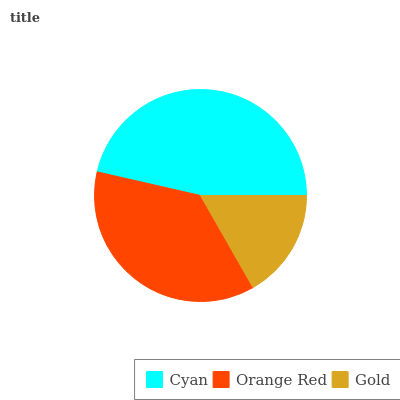Is Gold the minimum?
Answer yes or no. Yes. Is Cyan the maximum?
Answer yes or no. Yes. Is Orange Red the minimum?
Answer yes or no. No. Is Orange Red the maximum?
Answer yes or no. No. Is Cyan greater than Orange Red?
Answer yes or no. Yes. Is Orange Red less than Cyan?
Answer yes or no. Yes. Is Orange Red greater than Cyan?
Answer yes or no. No. Is Cyan less than Orange Red?
Answer yes or no. No. Is Orange Red the high median?
Answer yes or no. Yes. Is Orange Red the low median?
Answer yes or no. Yes. Is Cyan the high median?
Answer yes or no. No. Is Gold the low median?
Answer yes or no. No. 